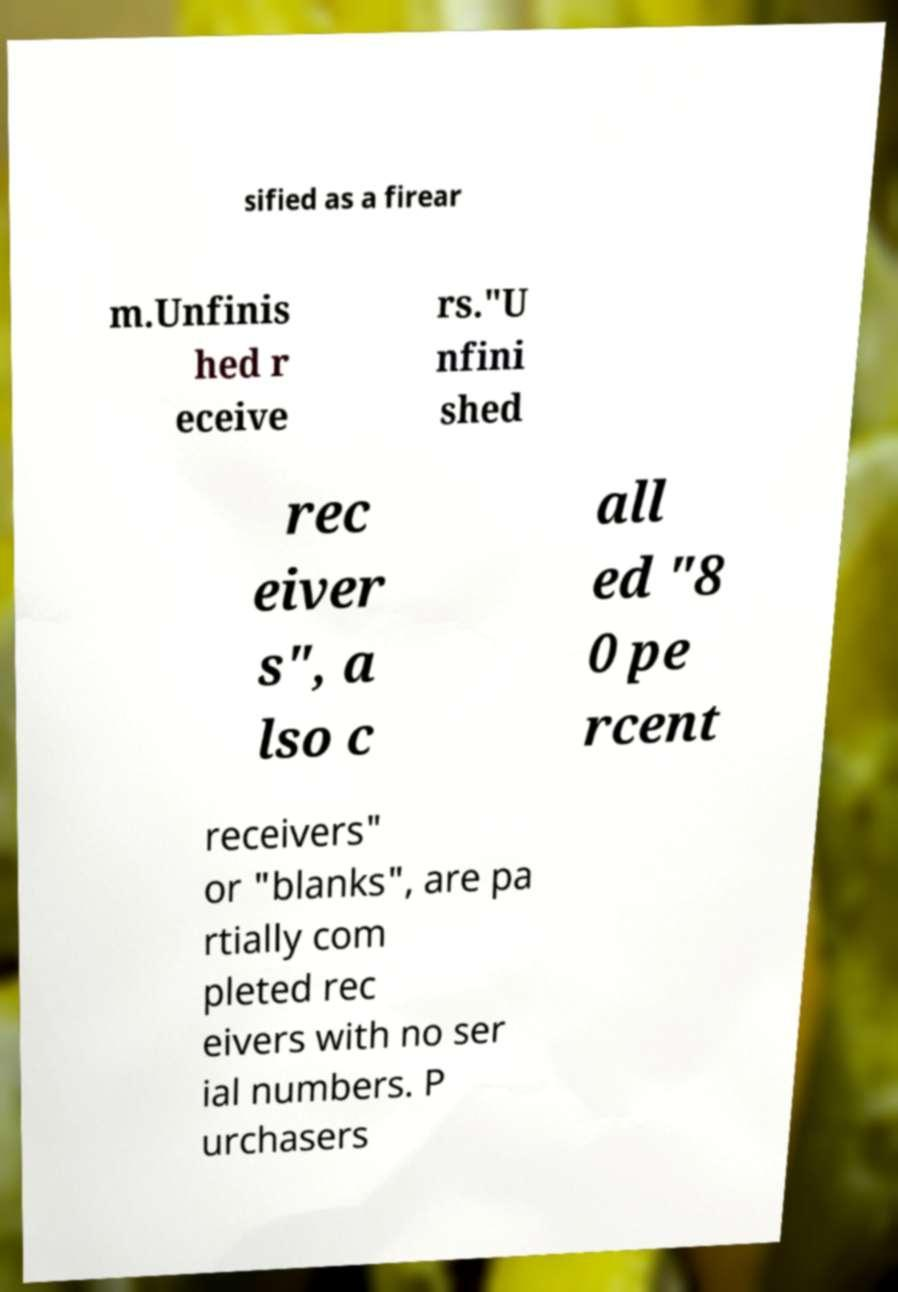There's text embedded in this image that I need extracted. Can you transcribe it verbatim? sified as a firear m.Unfinis hed r eceive rs."U nfini shed rec eiver s", a lso c all ed "8 0 pe rcent receivers" or "blanks", are pa rtially com pleted rec eivers with no ser ial numbers. P urchasers 